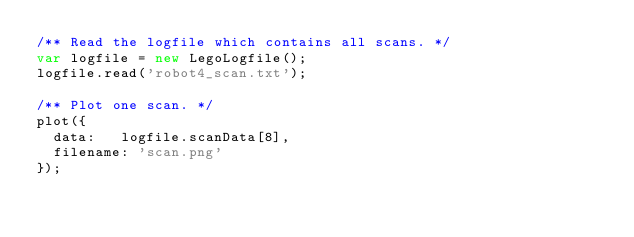<code> <loc_0><loc_0><loc_500><loc_500><_JavaScript_>/** Read the logfile which contains all scans. */
var logfile = new LegoLogfile();
logfile.read('robot4_scan.txt');

/** Plot one scan. */
plot({
  data:   logfile.scanData[8],
  filename: 'scan.png'
});</code> 